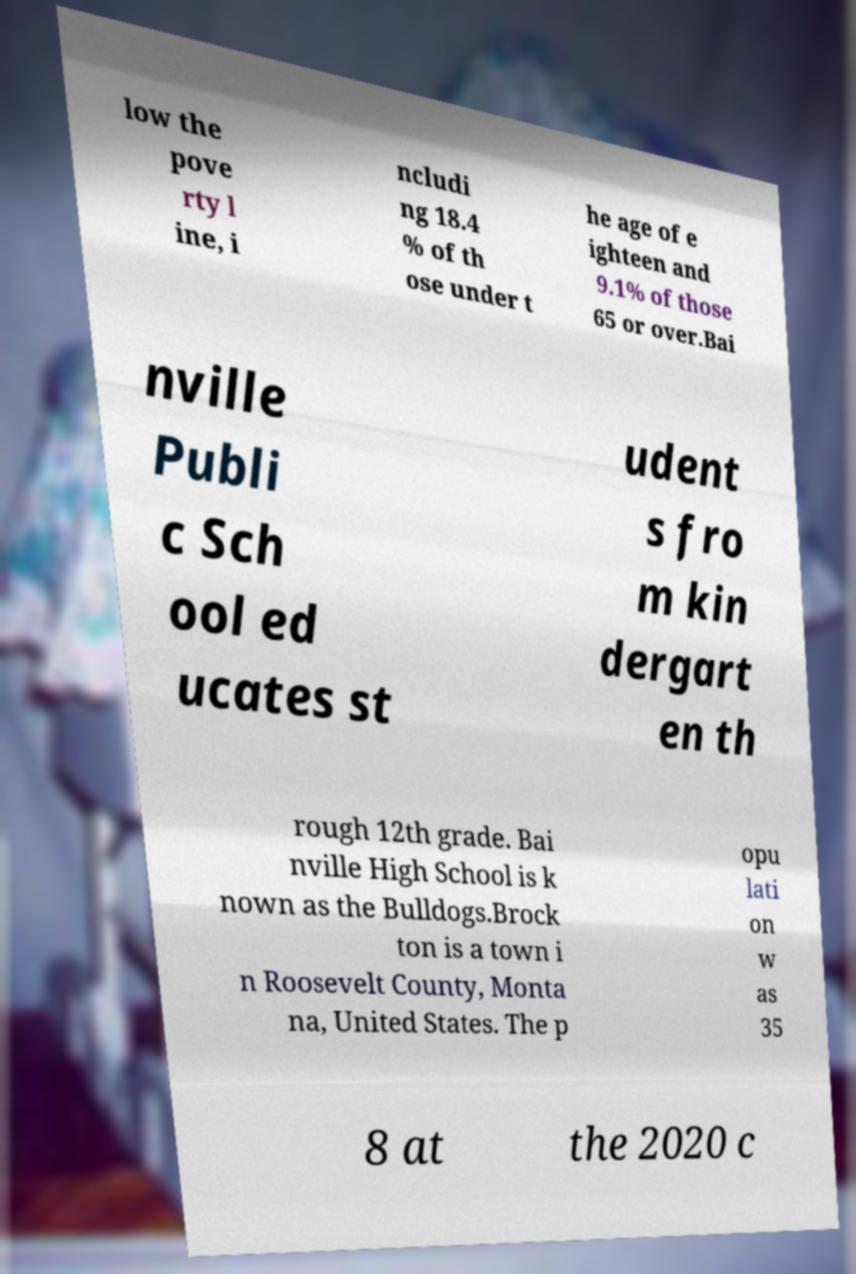For documentation purposes, I need the text within this image transcribed. Could you provide that? low the pove rty l ine, i ncludi ng 18.4 % of th ose under t he age of e ighteen and 9.1% of those 65 or over.Bai nville Publi c Sch ool ed ucates st udent s fro m kin dergart en th rough 12th grade. Bai nville High School is k nown as the Bulldogs.Brock ton is a town i n Roosevelt County, Monta na, United States. The p opu lati on w as 35 8 at the 2020 c 